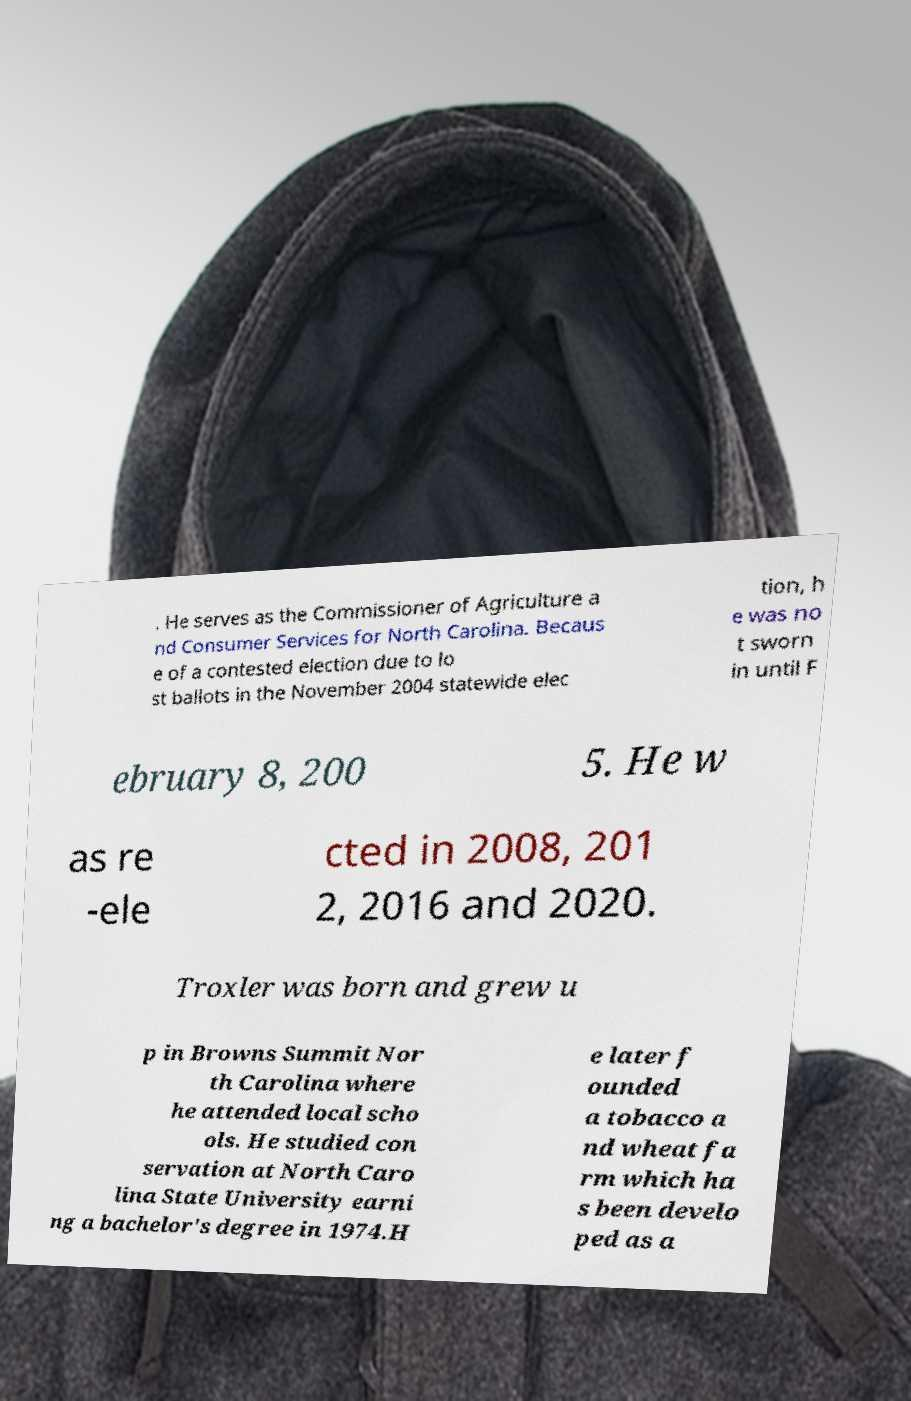Could you assist in decoding the text presented in this image and type it out clearly? . He serves as the Commissioner of Agriculture a nd Consumer Services for North Carolina. Becaus e of a contested election due to lo st ballots in the November 2004 statewide elec tion, h e was no t sworn in until F ebruary 8, 200 5. He w as re -ele cted in 2008, 201 2, 2016 and 2020. Troxler was born and grew u p in Browns Summit Nor th Carolina where he attended local scho ols. He studied con servation at North Caro lina State University earni ng a bachelor's degree in 1974.H e later f ounded a tobacco a nd wheat fa rm which ha s been develo ped as a 